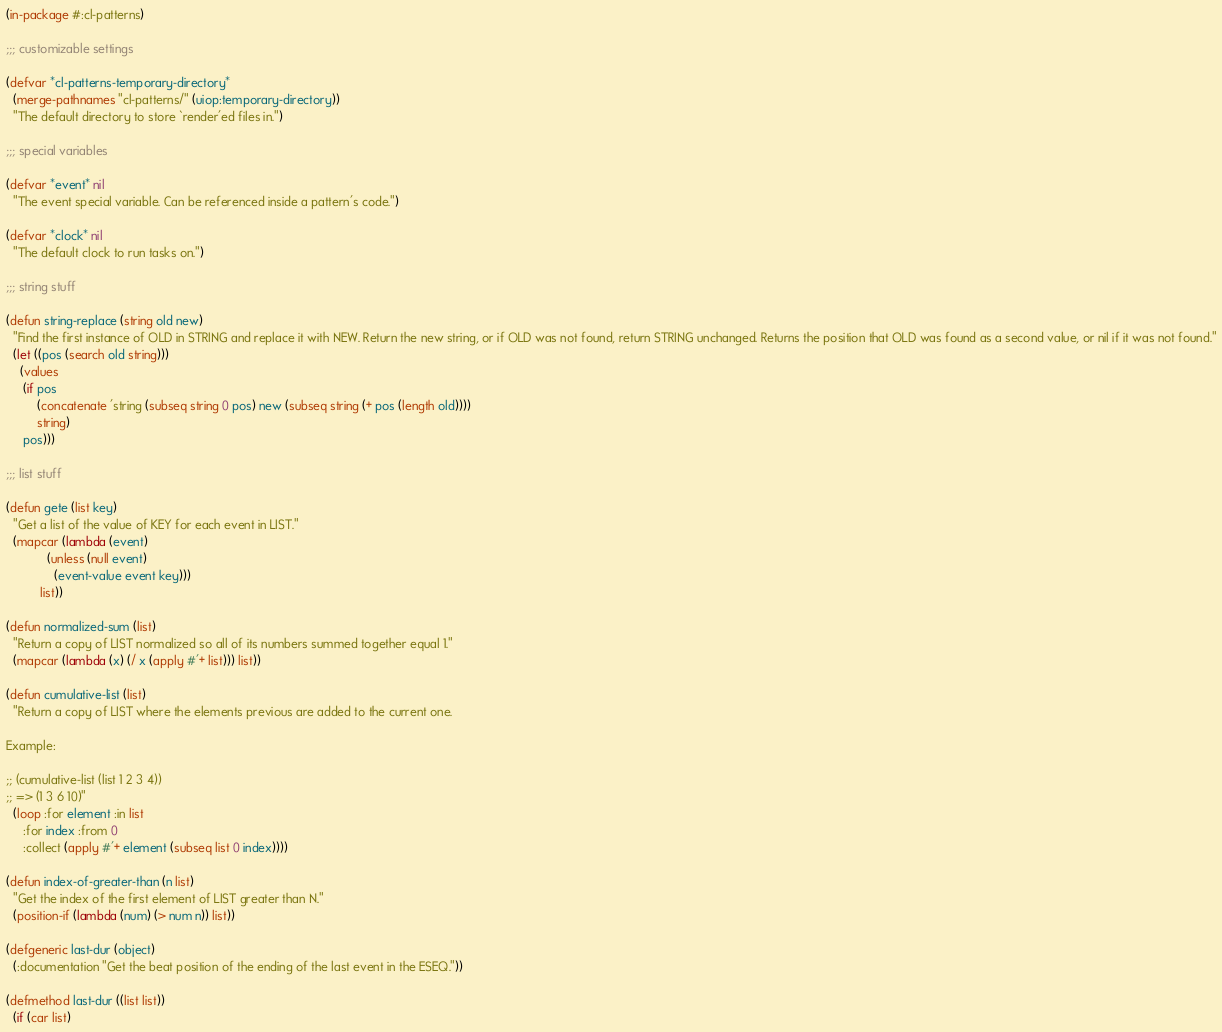<code> <loc_0><loc_0><loc_500><loc_500><_Lisp_>(in-package #:cl-patterns)

;;; customizable settings

(defvar *cl-patterns-temporary-directory*
  (merge-pathnames "cl-patterns/" (uiop:temporary-directory))
  "The default directory to store `render'ed files in.")

;;; special variables

(defvar *event* nil
  "The event special variable. Can be referenced inside a pattern's code.")

(defvar *clock* nil
  "The default clock to run tasks on.")

;;; string stuff

(defun string-replace (string old new)
  "Find the first instance of OLD in STRING and replace it with NEW. Return the new string, or if OLD was not found, return STRING unchanged. Returns the position that OLD was found as a second value, or nil if it was not found."
  (let ((pos (search old string)))
    (values
     (if pos
         (concatenate 'string (subseq string 0 pos) new (subseq string (+ pos (length old))))
         string)
     pos)))

;;; list stuff

(defun gete (list key)
  "Get a list of the value of KEY for each event in LIST."
  (mapcar (lambda (event)
            (unless (null event)
              (event-value event key)))
          list))

(defun normalized-sum (list)
  "Return a copy of LIST normalized so all of its numbers summed together equal 1."
  (mapcar (lambda (x) (/ x (apply #'+ list))) list))

(defun cumulative-list (list)
  "Return a copy of LIST where the elements previous are added to the current one.

Example:

;; (cumulative-list (list 1 2 3 4))
;; => (1 3 6 10)"
  (loop :for element :in list
     :for index :from 0
     :collect (apply #'+ element (subseq list 0 index))))

(defun index-of-greater-than (n list)
  "Get the index of the first element of LIST greater than N."
  (position-if (lambda (num) (> num n)) list))

(defgeneric last-dur (object)
  (:documentation "Get the beat position of the ending of the last event in the ESEQ."))

(defmethod last-dur ((list list))
  (if (car list)</code> 